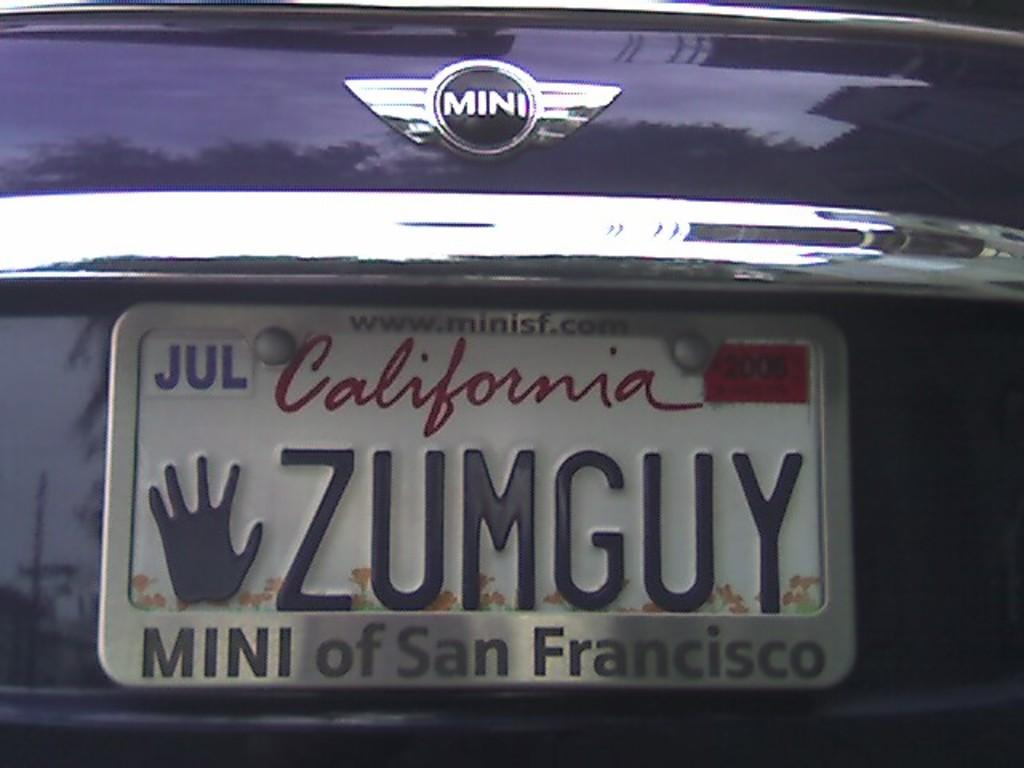Provide a one-sentence caption for the provided image. The mini car brand with a California tag on the back. 